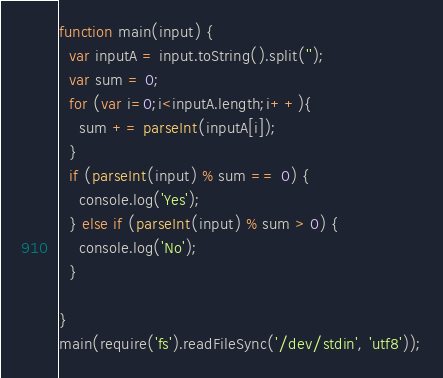Convert code to text. <code><loc_0><loc_0><loc_500><loc_500><_JavaScript_>function main(input) {
  var inputA = input.toString().split('');
  var sum = 0;
  for (var i=0;i<inputA.length;i++){
   	sum += parseInt(inputA[i]);
  }
  if (parseInt(input) % sum == 0) {
  	console.log('Yes');
  } else if (parseInt(input) % sum > 0) {
  	console.log('No');
  }
  
}
main(require('fs').readFileSync('/dev/stdin', 'utf8'));</code> 